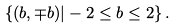Convert formula to latex. <formula><loc_0><loc_0><loc_500><loc_500>\left \{ ( b , \mp b ) | - 2 \leq b \leq 2 \right \} .</formula> 